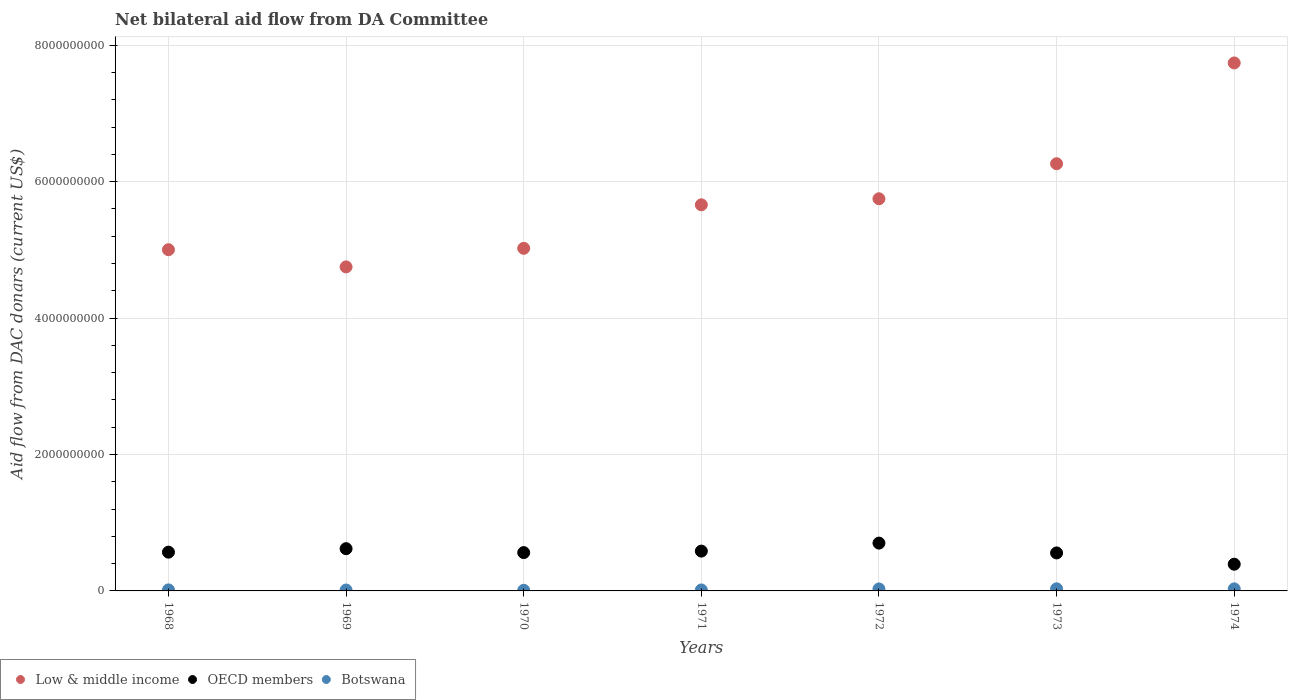Is the number of dotlines equal to the number of legend labels?
Provide a short and direct response. Yes. What is the aid flow in in Low & middle income in 1969?
Offer a terse response. 4.75e+09. Across all years, what is the maximum aid flow in in OECD members?
Provide a succinct answer. 7.01e+08. Across all years, what is the minimum aid flow in in Botswana?
Offer a terse response. 9.26e+06. In which year was the aid flow in in Low & middle income maximum?
Make the answer very short. 1974. In which year was the aid flow in in Low & middle income minimum?
Provide a short and direct response. 1969. What is the total aid flow in in Low & middle income in the graph?
Ensure brevity in your answer.  4.02e+1. What is the difference between the aid flow in in OECD members in 1971 and that in 1973?
Offer a very short reply. 2.68e+07. What is the difference between the aid flow in in Botswana in 1970 and the aid flow in in OECD members in 1974?
Offer a terse response. -3.82e+08. What is the average aid flow in in OECD members per year?
Your response must be concise. 5.69e+08. In the year 1970, what is the difference between the aid flow in in Low & middle income and aid flow in in Botswana?
Give a very brief answer. 5.01e+09. What is the ratio of the aid flow in in Botswana in 1968 to that in 1971?
Give a very brief answer. 1.09. Is the aid flow in in Botswana in 1969 less than that in 1971?
Offer a terse response. Yes. Is the difference between the aid flow in in Low & middle income in 1970 and 1972 greater than the difference between the aid flow in in Botswana in 1970 and 1972?
Give a very brief answer. No. What is the difference between the highest and the second highest aid flow in in OECD members?
Offer a very short reply. 8.19e+07. What is the difference between the highest and the lowest aid flow in in Low & middle income?
Offer a terse response. 2.99e+09. Is the sum of the aid flow in in OECD members in 1968 and 1972 greater than the maximum aid flow in in Low & middle income across all years?
Offer a terse response. No. How many years are there in the graph?
Your answer should be very brief. 7. Does the graph contain any zero values?
Give a very brief answer. No. Does the graph contain grids?
Your answer should be very brief. Yes. What is the title of the graph?
Offer a very short reply. Net bilateral aid flow from DA Committee. What is the label or title of the Y-axis?
Provide a succinct answer. Aid flow from DAC donars (current US$). What is the Aid flow from DAC donars (current US$) in Low & middle income in 1968?
Your answer should be compact. 5.00e+09. What is the Aid flow from DAC donars (current US$) in OECD members in 1968?
Ensure brevity in your answer.  5.68e+08. What is the Aid flow from DAC donars (current US$) of Botswana in 1968?
Offer a very short reply. 1.53e+07. What is the Aid flow from DAC donars (current US$) of Low & middle income in 1969?
Give a very brief answer. 4.75e+09. What is the Aid flow from DAC donars (current US$) in OECD members in 1969?
Give a very brief answer. 6.19e+08. What is the Aid flow from DAC donars (current US$) in Botswana in 1969?
Give a very brief answer. 1.32e+07. What is the Aid flow from DAC donars (current US$) of Low & middle income in 1970?
Offer a very short reply. 5.02e+09. What is the Aid flow from DAC donars (current US$) of OECD members in 1970?
Give a very brief answer. 5.62e+08. What is the Aid flow from DAC donars (current US$) of Botswana in 1970?
Provide a short and direct response. 9.26e+06. What is the Aid flow from DAC donars (current US$) of Low & middle income in 1971?
Provide a short and direct response. 5.66e+09. What is the Aid flow from DAC donars (current US$) in OECD members in 1971?
Offer a terse response. 5.84e+08. What is the Aid flow from DAC donars (current US$) of Botswana in 1971?
Keep it short and to the point. 1.40e+07. What is the Aid flow from DAC donars (current US$) in Low & middle income in 1972?
Your response must be concise. 5.75e+09. What is the Aid flow from DAC donars (current US$) in OECD members in 1972?
Ensure brevity in your answer.  7.01e+08. What is the Aid flow from DAC donars (current US$) of Botswana in 1972?
Offer a very short reply. 2.93e+07. What is the Aid flow from DAC donars (current US$) of Low & middle income in 1973?
Your answer should be compact. 6.26e+09. What is the Aid flow from DAC donars (current US$) of OECD members in 1973?
Make the answer very short. 5.57e+08. What is the Aid flow from DAC donars (current US$) in Botswana in 1973?
Keep it short and to the point. 3.09e+07. What is the Aid flow from DAC donars (current US$) of Low & middle income in 1974?
Make the answer very short. 7.74e+09. What is the Aid flow from DAC donars (current US$) in OECD members in 1974?
Make the answer very short. 3.92e+08. What is the Aid flow from DAC donars (current US$) of Botswana in 1974?
Keep it short and to the point. 2.99e+07. Across all years, what is the maximum Aid flow from DAC donars (current US$) in Low & middle income?
Provide a succinct answer. 7.74e+09. Across all years, what is the maximum Aid flow from DAC donars (current US$) in OECD members?
Your answer should be very brief. 7.01e+08. Across all years, what is the maximum Aid flow from DAC donars (current US$) of Botswana?
Provide a short and direct response. 3.09e+07. Across all years, what is the minimum Aid flow from DAC donars (current US$) in Low & middle income?
Provide a succinct answer. 4.75e+09. Across all years, what is the minimum Aid flow from DAC donars (current US$) in OECD members?
Provide a succinct answer. 3.92e+08. Across all years, what is the minimum Aid flow from DAC donars (current US$) in Botswana?
Give a very brief answer. 9.26e+06. What is the total Aid flow from DAC donars (current US$) of Low & middle income in the graph?
Your response must be concise. 4.02e+1. What is the total Aid flow from DAC donars (current US$) of OECD members in the graph?
Your response must be concise. 3.98e+09. What is the total Aid flow from DAC donars (current US$) of Botswana in the graph?
Provide a short and direct response. 1.42e+08. What is the difference between the Aid flow from DAC donars (current US$) of Low & middle income in 1968 and that in 1969?
Give a very brief answer. 2.52e+08. What is the difference between the Aid flow from DAC donars (current US$) of OECD members in 1968 and that in 1969?
Ensure brevity in your answer.  -5.08e+07. What is the difference between the Aid flow from DAC donars (current US$) of Botswana in 1968 and that in 1969?
Keep it short and to the point. 2.14e+06. What is the difference between the Aid flow from DAC donars (current US$) in Low & middle income in 1968 and that in 1970?
Ensure brevity in your answer.  -2.03e+07. What is the difference between the Aid flow from DAC donars (current US$) of OECD members in 1968 and that in 1970?
Provide a succinct answer. 6.41e+06. What is the difference between the Aid flow from DAC donars (current US$) in Botswana in 1968 and that in 1970?
Provide a short and direct response. 6.04e+06. What is the difference between the Aid flow from DAC donars (current US$) of Low & middle income in 1968 and that in 1971?
Give a very brief answer. -6.58e+08. What is the difference between the Aid flow from DAC donars (current US$) in OECD members in 1968 and that in 1971?
Keep it short and to the point. -1.54e+07. What is the difference between the Aid flow from DAC donars (current US$) of Botswana in 1968 and that in 1971?
Your response must be concise. 1.28e+06. What is the difference between the Aid flow from DAC donars (current US$) in Low & middle income in 1968 and that in 1972?
Your answer should be compact. -7.47e+08. What is the difference between the Aid flow from DAC donars (current US$) of OECD members in 1968 and that in 1972?
Your answer should be compact. -1.33e+08. What is the difference between the Aid flow from DAC donars (current US$) of Botswana in 1968 and that in 1972?
Offer a terse response. -1.40e+07. What is the difference between the Aid flow from DAC donars (current US$) of Low & middle income in 1968 and that in 1973?
Your answer should be very brief. -1.26e+09. What is the difference between the Aid flow from DAC donars (current US$) in OECD members in 1968 and that in 1973?
Keep it short and to the point. 1.14e+07. What is the difference between the Aid flow from DAC donars (current US$) of Botswana in 1968 and that in 1973?
Keep it short and to the point. -1.56e+07. What is the difference between the Aid flow from DAC donars (current US$) in Low & middle income in 1968 and that in 1974?
Make the answer very short. -2.74e+09. What is the difference between the Aid flow from DAC donars (current US$) in OECD members in 1968 and that in 1974?
Offer a very short reply. 1.77e+08. What is the difference between the Aid flow from DAC donars (current US$) of Botswana in 1968 and that in 1974?
Keep it short and to the point. -1.46e+07. What is the difference between the Aid flow from DAC donars (current US$) in Low & middle income in 1969 and that in 1970?
Offer a terse response. -2.72e+08. What is the difference between the Aid flow from DAC donars (current US$) of OECD members in 1969 and that in 1970?
Provide a succinct answer. 5.73e+07. What is the difference between the Aid flow from DAC donars (current US$) in Botswana in 1969 and that in 1970?
Provide a short and direct response. 3.90e+06. What is the difference between the Aid flow from DAC donars (current US$) of Low & middle income in 1969 and that in 1971?
Your answer should be compact. -9.10e+08. What is the difference between the Aid flow from DAC donars (current US$) of OECD members in 1969 and that in 1971?
Make the answer very short. 3.54e+07. What is the difference between the Aid flow from DAC donars (current US$) in Botswana in 1969 and that in 1971?
Give a very brief answer. -8.60e+05. What is the difference between the Aid flow from DAC donars (current US$) in Low & middle income in 1969 and that in 1972?
Your answer should be very brief. -9.99e+08. What is the difference between the Aid flow from DAC donars (current US$) in OECD members in 1969 and that in 1972?
Your response must be concise. -8.19e+07. What is the difference between the Aid flow from DAC donars (current US$) in Botswana in 1969 and that in 1972?
Keep it short and to the point. -1.61e+07. What is the difference between the Aid flow from DAC donars (current US$) in Low & middle income in 1969 and that in 1973?
Give a very brief answer. -1.51e+09. What is the difference between the Aid flow from DAC donars (current US$) in OECD members in 1969 and that in 1973?
Provide a short and direct response. 6.23e+07. What is the difference between the Aid flow from DAC donars (current US$) of Botswana in 1969 and that in 1973?
Provide a succinct answer. -1.78e+07. What is the difference between the Aid flow from DAC donars (current US$) of Low & middle income in 1969 and that in 1974?
Offer a very short reply. -2.99e+09. What is the difference between the Aid flow from DAC donars (current US$) of OECD members in 1969 and that in 1974?
Your answer should be compact. 2.28e+08. What is the difference between the Aid flow from DAC donars (current US$) of Botswana in 1969 and that in 1974?
Provide a succinct answer. -1.68e+07. What is the difference between the Aid flow from DAC donars (current US$) in Low & middle income in 1970 and that in 1971?
Give a very brief answer. -6.38e+08. What is the difference between the Aid flow from DAC donars (current US$) in OECD members in 1970 and that in 1971?
Keep it short and to the point. -2.18e+07. What is the difference between the Aid flow from DAC donars (current US$) of Botswana in 1970 and that in 1971?
Provide a short and direct response. -4.76e+06. What is the difference between the Aid flow from DAC donars (current US$) in Low & middle income in 1970 and that in 1972?
Provide a succinct answer. -7.26e+08. What is the difference between the Aid flow from DAC donars (current US$) in OECD members in 1970 and that in 1972?
Offer a very short reply. -1.39e+08. What is the difference between the Aid flow from DAC donars (current US$) of Botswana in 1970 and that in 1972?
Make the answer very short. -2.00e+07. What is the difference between the Aid flow from DAC donars (current US$) of Low & middle income in 1970 and that in 1973?
Your response must be concise. -1.24e+09. What is the difference between the Aid flow from DAC donars (current US$) in Botswana in 1970 and that in 1973?
Your answer should be compact. -2.17e+07. What is the difference between the Aid flow from DAC donars (current US$) in Low & middle income in 1970 and that in 1974?
Provide a short and direct response. -2.72e+09. What is the difference between the Aid flow from DAC donars (current US$) of OECD members in 1970 and that in 1974?
Your response must be concise. 1.70e+08. What is the difference between the Aid flow from DAC donars (current US$) of Botswana in 1970 and that in 1974?
Ensure brevity in your answer.  -2.07e+07. What is the difference between the Aid flow from DAC donars (current US$) of Low & middle income in 1971 and that in 1972?
Ensure brevity in your answer.  -8.87e+07. What is the difference between the Aid flow from DAC donars (current US$) of OECD members in 1971 and that in 1972?
Make the answer very short. -1.17e+08. What is the difference between the Aid flow from DAC donars (current US$) of Botswana in 1971 and that in 1972?
Offer a very short reply. -1.53e+07. What is the difference between the Aid flow from DAC donars (current US$) of Low & middle income in 1971 and that in 1973?
Offer a very short reply. -6.02e+08. What is the difference between the Aid flow from DAC donars (current US$) in OECD members in 1971 and that in 1973?
Provide a succinct answer. 2.68e+07. What is the difference between the Aid flow from DAC donars (current US$) of Botswana in 1971 and that in 1973?
Your answer should be compact. -1.69e+07. What is the difference between the Aid flow from DAC donars (current US$) in Low & middle income in 1971 and that in 1974?
Your answer should be compact. -2.08e+09. What is the difference between the Aid flow from DAC donars (current US$) in OECD members in 1971 and that in 1974?
Offer a very short reply. 1.92e+08. What is the difference between the Aid flow from DAC donars (current US$) in Botswana in 1971 and that in 1974?
Keep it short and to the point. -1.59e+07. What is the difference between the Aid flow from DAC donars (current US$) in Low & middle income in 1972 and that in 1973?
Offer a terse response. -5.14e+08. What is the difference between the Aid flow from DAC donars (current US$) in OECD members in 1972 and that in 1973?
Ensure brevity in your answer.  1.44e+08. What is the difference between the Aid flow from DAC donars (current US$) in Botswana in 1972 and that in 1973?
Offer a terse response. -1.63e+06. What is the difference between the Aid flow from DAC donars (current US$) of Low & middle income in 1972 and that in 1974?
Ensure brevity in your answer.  -1.99e+09. What is the difference between the Aid flow from DAC donars (current US$) of OECD members in 1972 and that in 1974?
Keep it short and to the point. 3.10e+08. What is the difference between the Aid flow from DAC donars (current US$) of Botswana in 1972 and that in 1974?
Give a very brief answer. -6.50e+05. What is the difference between the Aid flow from DAC donars (current US$) in Low & middle income in 1973 and that in 1974?
Give a very brief answer. -1.48e+09. What is the difference between the Aid flow from DAC donars (current US$) in OECD members in 1973 and that in 1974?
Provide a short and direct response. 1.65e+08. What is the difference between the Aid flow from DAC donars (current US$) in Botswana in 1973 and that in 1974?
Your answer should be very brief. 9.80e+05. What is the difference between the Aid flow from DAC donars (current US$) in Low & middle income in 1968 and the Aid flow from DAC donars (current US$) in OECD members in 1969?
Offer a very short reply. 4.38e+09. What is the difference between the Aid flow from DAC donars (current US$) of Low & middle income in 1968 and the Aid flow from DAC donars (current US$) of Botswana in 1969?
Make the answer very short. 4.99e+09. What is the difference between the Aid flow from DAC donars (current US$) of OECD members in 1968 and the Aid flow from DAC donars (current US$) of Botswana in 1969?
Offer a terse response. 5.55e+08. What is the difference between the Aid flow from DAC donars (current US$) of Low & middle income in 1968 and the Aid flow from DAC donars (current US$) of OECD members in 1970?
Your answer should be compact. 4.44e+09. What is the difference between the Aid flow from DAC donars (current US$) of Low & middle income in 1968 and the Aid flow from DAC donars (current US$) of Botswana in 1970?
Offer a very short reply. 4.99e+09. What is the difference between the Aid flow from DAC donars (current US$) of OECD members in 1968 and the Aid flow from DAC donars (current US$) of Botswana in 1970?
Keep it short and to the point. 5.59e+08. What is the difference between the Aid flow from DAC donars (current US$) of Low & middle income in 1968 and the Aid flow from DAC donars (current US$) of OECD members in 1971?
Your answer should be very brief. 4.42e+09. What is the difference between the Aid flow from DAC donars (current US$) in Low & middle income in 1968 and the Aid flow from DAC donars (current US$) in Botswana in 1971?
Provide a short and direct response. 4.99e+09. What is the difference between the Aid flow from DAC donars (current US$) of OECD members in 1968 and the Aid flow from DAC donars (current US$) of Botswana in 1971?
Provide a succinct answer. 5.54e+08. What is the difference between the Aid flow from DAC donars (current US$) of Low & middle income in 1968 and the Aid flow from DAC donars (current US$) of OECD members in 1972?
Your answer should be compact. 4.30e+09. What is the difference between the Aid flow from DAC donars (current US$) of Low & middle income in 1968 and the Aid flow from DAC donars (current US$) of Botswana in 1972?
Provide a short and direct response. 4.97e+09. What is the difference between the Aid flow from DAC donars (current US$) of OECD members in 1968 and the Aid flow from DAC donars (current US$) of Botswana in 1972?
Provide a succinct answer. 5.39e+08. What is the difference between the Aid flow from DAC donars (current US$) in Low & middle income in 1968 and the Aid flow from DAC donars (current US$) in OECD members in 1973?
Your answer should be compact. 4.45e+09. What is the difference between the Aid flow from DAC donars (current US$) of Low & middle income in 1968 and the Aid flow from DAC donars (current US$) of Botswana in 1973?
Give a very brief answer. 4.97e+09. What is the difference between the Aid flow from DAC donars (current US$) of OECD members in 1968 and the Aid flow from DAC donars (current US$) of Botswana in 1973?
Your answer should be very brief. 5.37e+08. What is the difference between the Aid flow from DAC donars (current US$) in Low & middle income in 1968 and the Aid flow from DAC donars (current US$) in OECD members in 1974?
Offer a very short reply. 4.61e+09. What is the difference between the Aid flow from DAC donars (current US$) in Low & middle income in 1968 and the Aid flow from DAC donars (current US$) in Botswana in 1974?
Give a very brief answer. 4.97e+09. What is the difference between the Aid flow from DAC donars (current US$) of OECD members in 1968 and the Aid flow from DAC donars (current US$) of Botswana in 1974?
Your answer should be very brief. 5.38e+08. What is the difference between the Aid flow from DAC donars (current US$) in Low & middle income in 1969 and the Aid flow from DAC donars (current US$) in OECD members in 1970?
Give a very brief answer. 4.19e+09. What is the difference between the Aid flow from DAC donars (current US$) in Low & middle income in 1969 and the Aid flow from DAC donars (current US$) in Botswana in 1970?
Give a very brief answer. 4.74e+09. What is the difference between the Aid flow from DAC donars (current US$) in OECD members in 1969 and the Aid flow from DAC donars (current US$) in Botswana in 1970?
Provide a succinct answer. 6.10e+08. What is the difference between the Aid flow from DAC donars (current US$) in Low & middle income in 1969 and the Aid flow from DAC donars (current US$) in OECD members in 1971?
Provide a short and direct response. 4.17e+09. What is the difference between the Aid flow from DAC donars (current US$) in Low & middle income in 1969 and the Aid flow from DAC donars (current US$) in Botswana in 1971?
Give a very brief answer. 4.74e+09. What is the difference between the Aid flow from DAC donars (current US$) of OECD members in 1969 and the Aid flow from DAC donars (current US$) of Botswana in 1971?
Ensure brevity in your answer.  6.05e+08. What is the difference between the Aid flow from DAC donars (current US$) in Low & middle income in 1969 and the Aid flow from DAC donars (current US$) in OECD members in 1972?
Your answer should be compact. 4.05e+09. What is the difference between the Aid flow from DAC donars (current US$) of Low & middle income in 1969 and the Aid flow from DAC donars (current US$) of Botswana in 1972?
Make the answer very short. 4.72e+09. What is the difference between the Aid flow from DAC donars (current US$) in OECD members in 1969 and the Aid flow from DAC donars (current US$) in Botswana in 1972?
Your answer should be compact. 5.90e+08. What is the difference between the Aid flow from DAC donars (current US$) of Low & middle income in 1969 and the Aid flow from DAC donars (current US$) of OECD members in 1973?
Offer a very short reply. 4.19e+09. What is the difference between the Aid flow from DAC donars (current US$) in Low & middle income in 1969 and the Aid flow from DAC donars (current US$) in Botswana in 1973?
Provide a succinct answer. 4.72e+09. What is the difference between the Aid flow from DAC donars (current US$) in OECD members in 1969 and the Aid flow from DAC donars (current US$) in Botswana in 1973?
Make the answer very short. 5.88e+08. What is the difference between the Aid flow from DAC donars (current US$) of Low & middle income in 1969 and the Aid flow from DAC donars (current US$) of OECD members in 1974?
Your answer should be very brief. 4.36e+09. What is the difference between the Aid flow from DAC donars (current US$) in Low & middle income in 1969 and the Aid flow from DAC donars (current US$) in Botswana in 1974?
Offer a very short reply. 4.72e+09. What is the difference between the Aid flow from DAC donars (current US$) of OECD members in 1969 and the Aid flow from DAC donars (current US$) of Botswana in 1974?
Your answer should be compact. 5.89e+08. What is the difference between the Aid flow from DAC donars (current US$) of Low & middle income in 1970 and the Aid flow from DAC donars (current US$) of OECD members in 1971?
Offer a very short reply. 4.44e+09. What is the difference between the Aid flow from DAC donars (current US$) in Low & middle income in 1970 and the Aid flow from DAC donars (current US$) in Botswana in 1971?
Provide a succinct answer. 5.01e+09. What is the difference between the Aid flow from DAC donars (current US$) in OECD members in 1970 and the Aid flow from DAC donars (current US$) in Botswana in 1971?
Provide a succinct answer. 5.48e+08. What is the difference between the Aid flow from DAC donars (current US$) of Low & middle income in 1970 and the Aid flow from DAC donars (current US$) of OECD members in 1972?
Give a very brief answer. 4.32e+09. What is the difference between the Aid flow from DAC donars (current US$) of Low & middle income in 1970 and the Aid flow from DAC donars (current US$) of Botswana in 1972?
Provide a short and direct response. 4.99e+09. What is the difference between the Aid flow from DAC donars (current US$) in OECD members in 1970 and the Aid flow from DAC donars (current US$) in Botswana in 1972?
Your answer should be compact. 5.33e+08. What is the difference between the Aid flow from DAC donars (current US$) of Low & middle income in 1970 and the Aid flow from DAC donars (current US$) of OECD members in 1973?
Make the answer very short. 4.47e+09. What is the difference between the Aid flow from DAC donars (current US$) of Low & middle income in 1970 and the Aid flow from DAC donars (current US$) of Botswana in 1973?
Make the answer very short. 4.99e+09. What is the difference between the Aid flow from DAC donars (current US$) of OECD members in 1970 and the Aid flow from DAC donars (current US$) of Botswana in 1973?
Your response must be concise. 5.31e+08. What is the difference between the Aid flow from DAC donars (current US$) in Low & middle income in 1970 and the Aid flow from DAC donars (current US$) in OECD members in 1974?
Offer a terse response. 4.63e+09. What is the difference between the Aid flow from DAC donars (current US$) of Low & middle income in 1970 and the Aid flow from DAC donars (current US$) of Botswana in 1974?
Your response must be concise. 4.99e+09. What is the difference between the Aid flow from DAC donars (current US$) in OECD members in 1970 and the Aid flow from DAC donars (current US$) in Botswana in 1974?
Provide a succinct answer. 5.32e+08. What is the difference between the Aid flow from DAC donars (current US$) of Low & middle income in 1971 and the Aid flow from DAC donars (current US$) of OECD members in 1972?
Your answer should be very brief. 4.96e+09. What is the difference between the Aid flow from DAC donars (current US$) in Low & middle income in 1971 and the Aid flow from DAC donars (current US$) in Botswana in 1972?
Your response must be concise. 5.63e+09. What is the difference between the Aid flow from DAC donars (current US$) of OECD members in 1971 and the Aid flow from DAC donars (current US$) of Botswana in 1972?
Keep it short and to the point. 5.55e+08. What is the difference between the Aid flow from DAC donars (current US$) of Low & middle income in 1971 and the Aid flow from DAC donars (current US$) of OECD members in 1973?
Offer a very short reply. 5.10e+09. What is the difference between the Aid flow from DAC donars (current US$) of Low & middle income in 1971 and the Aid flow from DAC donars (current US$) of Botswana in 1973?
Offer a terse response. 5.63e+09. What is the difference between the Aid flow from DAC donars (current US$) of OECD members in 1971 and the Aid flow from DAC donars (current US$) of Botswana in 1973?
Your answer should be compact. 5.53e+08. What is the difference between the Aid flow from DAC donars (current US$) of Low & middle income in 1971 and the Aid flow from DAC donars (current US$) of OECD members in 1974?
Offer a very short reply. 5.27e+09. What is the difference between the Aid flow from DAC donars (current US$) of Low & middle income in 1971 and the Aid flow from DAC donars (current US$) of Botswana in 1974?
Your response must be concise. 5.63e+09. What is the difference between the Aid flow from DAC donars (current US$) of OECD members in 1971 and the Aid flow from DAC donars (current US$) of Botswana in 1974?
Make the answer very short. 5.54e+08. What is the difference between the Aid flow from DAC donars (current US$) in Low & middle income in 1972 and the Aid flow from DAC donars (current US$) in OECD members in 1973?
Offer a terse response. 5.19e+09. What is the difference between the Aid flow from DAC donars (current US$) of Low & middle income in 1972 and the Aid flow from DAC donars (current US$) of Botswana in 1973?
Your response must be concise. 5.72e+09. What is the difference between the Aid flow from DAC donars (current US$) in OECD members in 1972 and the Aid flow from DAC donars (current US$) in Botswana in 1973?
Ensure brevity in your answer.  6.70e+08. What is the difference between the Aid flow from DAC donars (current US$) of Low & middle income in 1972 and the Aid flow from DAC donars (current US$) of OECD members in 1974?
Your answer should be very brief. 5.36e+09. What is the difference between the Aid flow from DAC donars (current US$) in Low & middle income in 1972 and the Aid flow from DAC donars (current US$) in Botswana in 1974?
Provide a short and direct response. 5.72e+09. What is the difference between the Aid flow from DAC donars (current US$) in OECD members in 1972 and the Aid flow from DAC donars (current US$) in Botswana in 1974?
Keep it short and to the point. 6.71e+08. What is the difference between the Aid flow from DAC donars (current US$) of Low & middle income in 1973 and the Aid flow from DAC donars (current US$) of OECD members in 1974?
Make the answer very short. 5.87e+09. What is the difference between the Aid flow from DAC donars (current US$) in Low & middle income in 1973 and the Aid flow from DAC donars (current US$) in Botswana in 1974?
Give a very brief answer. 6.23e+09. What is the difference between the Aid flow from DAC donars (current US$) of OECD members in 1973 and the Aid flow from DAC donars (current US$) of Botswana in 1974?
Offer a terse response. 5.27e+08. What is the average Aid flow from DAC donars (current US$) in Low & middle income per year?
Keep it short and to the point. 5.74e+09. What is the average Aid flow from DAC donars (current US$) in OECD members per year?
Your answer should be very brief. 5.69e+08. What is the average Aid flow from DAC donars (current US$) in Botswana per year?
Make the answer very short. 2.03e+07. In the year 1968, what is the difference between the Aid flow from DAC donars (current US$) of Low & middle income and Aid flow from DAC donars (current US$) of OECD members?
Make the answer very short. 4.43e+09. In the year 1968, what is the difference between the Aid flow from DAC donars (current US$) of Low & middle income and Aid flow from DAC donars (current US$) of Botswana?
Make the answer very short. 4.99e+09. In the year 1968, what is the difference between the Aid flow from DAC donars (current US$) of OECD members and Aid flow from DAC donars (current US$) of Botswana?
Your answer should be very brief. 5.53e+08. In the year 1969, what is the difference between the Aid flow from DAC donars (current US$) of Low & middle income and Aid flow from DAC donars (current US$) of OECD members?
Keep it short and to the point. 4.13e+09. In the year 1969, what is the difference between the Aid flow from DAC donars (current US$) in Low & middle income and Aid flow from DAC donars (current US$) in Botswana?
Make the answer very short. 4.74e+09. In the year 1969, what is the difference between the Aid flow from DAC donars (current US$) in OECD members and Aid flow from DAC donars (current US$) in Botswana?
Your answer should be very brief. 6.06e+08. In the year 1970, what is the difference between the Aid flow from DAC donars (current US$) in Low & middle income and Aid flow from DAC donars (current US$) in OECD members?
Give a very brief answer. 4.46e+09. In the year 1970, what is the difference between the Aid flow from DAC donars (current US$) in Low & middle income and Aid flow from DAC donars (current US$) in Botswana?
Offer a terse response. 5.01e+09. In the year 1970, what is the difference between the Aid flow from DAC donars (current US$) in OECD members and Aid flow from DAC donars (current US$) in Botswana?
Make the answer very short. 5.53e+08. In the year 1971, what is the difference between the Aid flow from DAC donars (current US$) in Low & middle income and Aid flow from DAC donars (current US$) in OECD members?
Ensure brevity in your answer.  5.08e+09. In the year 1971, what is the difference between the Aid flow from DAC donars (current US$) of Low & middle income and Aid flow from DAC donars (current US$) of Botswana?
Offer a very short reply. 5.65e+09. In the year 1971, what is the difference between the Aid flow from DAC donars (current US$) of OECD members and Aid flow from DAC donars (current US$) of Botswana?
Offer a terse response. 5.70e+08. In the year 1972, what is the difference between the Aid flow from DAC donars (current US$) in Low & middle income and Aid flow from DAC donars (current US$) in OECD members?
Offer a terse response. 5.05e+09. In the year 1972, what is the difference between the Aid flow from DAC donars (current US$) in Low & middle income and Aid flow from DAC donars (current US$) in Botswana?
Your answer should be very brief. 5.72e+09. In the year 1972, what is the difference between the Aid flow from DAC donars (current US$) in OECD members and Aid flow from DAC donars (current US$) in Botswana?
Provide a succinct answer. 6.72e+08. In the year 1973, what is the difference between the Aid flow from DAC donars (current US$) in Low & middle income and Aid flow from DAC donars (current US$) in OECD members?
Offer a very short reply. 5.71e+09. In the year 1973, what is the difference between the Aid flow from DAC donars (current US$) in Low & middle income and Aid flow from DAC donars (current US$) in Botswana?
Your response must be concise. 6.23e+09. In the year 1973, what is the difference between the Aid flow from DAC donars (current US$) of OECD members and Aid flow from DAC donars (current US$) of Botswana?
Make the answer very short. 5.26e+08. In the year 1974, what is the difference between the Aid flow from DAC donars (current US$) in Low & middle income and Aid flow from DAC donars (current US$) in OECD members?
Your answer should be very brief. 7.35e+09. In the year 1974, what is the difference between the Aid flow from DAC donars (current US$) in Low & middle income and Aid flow from DAC donars (current US$) in Botswana?
Ensure brevity in your answer.  7.71e+09. In the year 1974, what is the difference between the Aid flow from DAC donars (current US$) in OECD members and Aid flow from DAC donars (current US$) in Botswana?
Keep it short and to the point. 3.62e+08. What is the ratio of the Aid flow from DAC donars (current US$) in Low & middle income in 1968 to that in 1969?
Provide a short and direct response. 1.05. What is the ratio of the Aid flow from DAC donars (current US$) of OECD members in 1968 to that in 1969?
Your response must be concise. 0.92. What is the ratio of the Aid flow from DAC donars (current US$) in Botswana in 1968 to that in 1969?
Offer a terse response. 1.16. What is the ratio of the Aid flow from DAC donars (current US$) of OECD members in 1968 to that in 1970?
Your answer should be compact. 1.01. What is the ratio of the Aid flow from DAC donars (current US$) of Botswana in 1968 to that in 1970?
Your answer should be compact. 1.65. What is the ratio of the Aid flow from DAC donars (current US$) in Low & middle income in 1968 to that in 1971?
Provide a succinct answer. 0.88. What is the ratio of the Aid flow from DAC donars (current US$) in OECD members in 1968 to that in 1971?
Your answer should be compact. 0.97. What is the ratio of the Aid flow from DAC donars (current US$) of Botswana in 1968 to that in 1971?
Offer a terse response. 1.09. What is the ratio of the Aid flow from DAC donars (current US$) in Low & middle income in 1968 to that in 1972?
Give a very brief answer. 0.87. What is the ratio of the Aid flow from DAC donars (current US$) of OECD members in 1968 to that in 1972?
Provide a succinct answer. 0.81. What is the ratio of the Aid flow from DAC donars (current US$) of Botswana in 1968 to that in 1972?
Ensure brevity in your answer.  0.52. What is the ratio of the Aid flow from DAC donars (current US$) in Low & middle income in 1968 to that in 1973?
Offer a terse response. 0.8. What is the ratio of the Aid flow from DAC donars (current US$) of OECD members in 1968 to that in 1973?
Your answer should be very brief. 1.02. What is the ratio of the Aid flow from DAC donars (current US$) of Botswana in 1968 to that in 1973?
Keep it short and to the point. 0.49. What is the ratio of the Aid flow from DAC donars (current US$) of Low & middle income in 1968 to that in 1974?
Give a very brief answer. 0.65. What is the ratio of the Aid flow from DAC donars (current US$) in OECD members in 1968 to that in 1974?
Your response must be concise. 1.45. What is the ratio of the Aid flow from DAC donars (current US$) of Botswana in 1968 to that in 1974?
Your answer should be very brief. 0.51. What is the ratio of the Aid flow from DAC donars (current US$) of Low & middle income in 1969 to that in 1970?
Offer a very short reply. 0.95. What is the ratio of the Aid flow from DAC donars (current US$) of OECD members in 1969 to that in 1970?
Your answer should be compact. 1.1. What is the ratio of the Aid flow from DAC donars (current US$) of Botswana in 1969 to that in 1970?
Your answer should be very brief. 1.42. What is the ratio of the Aid flow from DAC donars (current US$) in Low & middle income in 1969 to that in 1971?
Make the answer very short. 0.84. What is the ratio of the Aid flow from DAC donars (current US$) of OECD members in 1969 to that in 1971?
Provide a succinct answer. 1.06. What is the ratio of the Aid flow from DAC donars (current US$) of Botswana in 1969 to that in 1971?
Ensure brevity in your answer.  0.94. What is the ratio of the Aid flow from DAC donars (current US$) of Low & middle income in 1969 to that in 1972?
Keep it short and to the point. 0.83. What is the ratio of the Aid flow from DAC donars (current US$) of OECD members in 1969 to that in 1972?
Provide a succinct answer. 0.88. What is the ratio of the Aid flow from DAC donars (current US$) of Botswana in 1969 to that in 1972?
Offer a terse response. 0.45. What is the ratio of the Aid flow from DAC donars (current US$) of Low & middle income in 1969 to that in 1973?
Offer a very short reply. 0.76. What is the ratio of the Aid flow from DAC donars (current US$) of OECD members in 1969 to that in 1973?
Offer a very short reply. 1.11. What is the ratio of the Aid flow from DAC donars (current US$) of Botswana in 1969 to that in 1973?
Your answer should be compact. 0.43. What is the ratio of the Aid flow from DAC donars (current US$) in Low & middle income in 1969 to that in 1974?
Your answer should be very brief. 0.61. What is the ratio of the Aid flow from DAC donars (current US$) in OECD members in 1969 to that in 1974?
Give a very brief answer. 1.58. What is the ratio of the Aid flow from DAC donars (current US$) of Botswana in 1969 to that in 1974?
Make the answer very short. 0.44. What is the ratio of the Aid flow from DAC donars (current US$) of Low & middle income in 1970 to that in 1971?
Your response must be concise. 0.89. What is the ratio of the Aid flow from DAC donars (current US$) in OECD members in 1970 to that in 1971?
Give a very brief answer. 0.96. What is the ratio of the Aid flow from DAC donars (current US$) in Botswana in 1970 to that in 1971?
Offer a very short reply. 0.66. What is the ratio of the Aid flow from DAC donars (current US$) of Low & middle income in 1970 to that in 1972?
Ensure brevity in your answer.  0.87. What is the ratio of the Aid flow from DAC donars (current US$) in OECD members in 1970 to that in 1972?
Offer a terse response. 0.8. What is the ratio of the Aid flow from DAC donars (current US$) of Botswana in 1970 to that in 1972?
Provide a succinct answer. 0.32. What is the ratio of the Aid flow from DAC donars (current US$) of Low & middle income in 1970 to that in 1973?
Provide a succinct answer. 0.8. What is the ratio of the Aid flow from DAC donars (current US$) in OECD members in 1970 to that in 1973?
Give a very brief answer. 1.01. What is the ratio of the Aid flow from DAC donars (current US$) in Botswana in 1970 to that in 1973?
Make the answer very short. 0.3. What is the ratio of the Aid flow from DAC donars (current US$) of Low & middle income in 1970 to that in 1974?
Keep it short and to the point. 0.65. What is the ratio of the Aid flow from DAC donars (current US$) of OECD members in 1970 to that in 1974?
Provide a short and direct response. 1.44. What is the ratio of the Aid flow from DAC donars (current US$) in Botswana in 1970 to that in 1974?
Give a very brief answer. 0.31. What is the ratio of the Aid flow from DAC donars (current US$) of Low & middle income in 1971 to that in 1972?
Your answer should be compact. 0.98. What is the ratio of the Aid flow from DAC donars (current US$) in OECD members in 1971 to that in 1972?
Offer a very short reply. 0.83. What is the ratio of the Aid flow from DAC donars (current US$) of Botswana in 1971 to that in 1972?
Give a very brief answer. 0.48. What is the ratio of the Aid flow from DAC donars (current US$) of Low & middle income in 1971 to that in 1973?
Your answer should be very brief. 0.9. What is the ratio of the Aid flow from DAC donars (current US$) in OECD members in 1971 to that in 1973?
Provide a short and direct response. 1.05. What is the ratio of the Aid flow from DAC donars (current US$) in Botswana in 1971 to that in 1973?
Your answer should be very brief. 0.45. What is the ratio of the Aid flow from DAC donars (current US$) in Low & middle income in 1971 to that in 1974?
Your answer should be very brief. 0.73. What is the ratio of the Aid flow from DAC donars (current US$) in OECD members in 1971 to that in 1974?
Your answer should be compact. 1.49. What is the ratio of the Aid flow from DAC donars (current US$) of Botswana in 1971 to that in 1974?
Ensure brevity in your answer.  0.47. What is the ratio of the Aid flow from DAC donars (current US$) of Low & middle income in 1972 to that in 1973?
Your answer should be very brief. 0.92. What is the ratio of the Aid flow from DAC donars (current US$) of OECD members in 1972 to that in 1973?
Provide a succinct answer. 1.26. What is the ratio of the Aid flow from DAC donars (current US$) in Botswana in 1972 to that in 1973?
Provide a short and direct response. 0.95. What is the ratio of the Aid flow from DAC donars (current US$) of Low & middle income in 1972 to that in 1974?
Provide a short and direct response. 0.74. What is the ratio of the Aid flow from DAC donars (current US$) of OECD members in 1972 to that in 1974?
Keep it short and to the point. 1.79. What is the ratio of the Aid flow from DAC donars (current US$) of Botswana in 1972 to that in 1974?
Your answer should be compact. 0.98. What is the ratio of the Aid flow from DAC donars (current US$) in Low & middle income in 1973 to that in 1974?
Keep it short and to the point. 0.81. What is the ratio of the Aid flow from DAC donars (current US$) in OECD members in 1973 to that in 1974?
Offer a terse response. 1.42. What is the ratio of the Aid flow from DAC donars (current US$) in Botswana in 1973 to that in 1974?
Give a very brief answer. 1.03. What is the difference between the highest and the second highest Aid flow from DAC donars (current US$) of Low & middle income?
Your answer should be very brief. 1.48e+09. What is the difference between the highest and the second highest Aid flow from DAC donars (current US$) in OECD members?
Keep it short and to the point. 8.19e+07. What is the difference between the highest and the second highest Aid flow from DAC donars (current US$) in Botswana?
Make the answer very short. 9.80e+05. What is the difference between the highest and the lowest Aid flow from DAC donars (current US$) of Low & middle income?
Keep it short and to the point. 2.99e+09. What is the difference between the highest and the lowest Aid flow from DAC donars (current US$) of OECD members?
Give a very brief answer. 3.10e+08. What is the difference between the highest and the lowest Aid flow from DAC donars (current US$) of Botswana?
Give a very brief answer. 2.17e+07. 